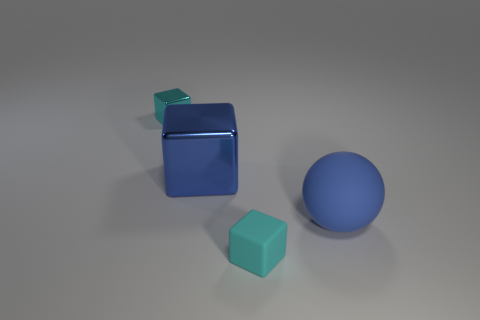Add 2 blue shiny blocks. How many objects exist? 6 Subtract all blocks. How many objects are left? 1 Add 3 large purple metallic cylinders. How many large purple metallic cylinders exist? 3 Subtract 0 green cylinders. How many objects are left? 4 Subtract all big blue spheres. Subtract all tiny things. How many objects are left? 1 Add 1 cyan blocks. How many cyan blocks are left? 3 